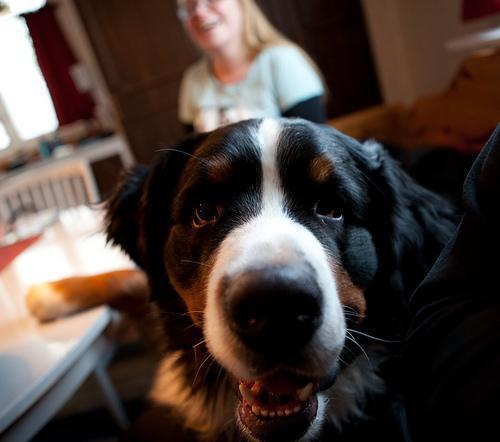How many of the dog's teeth are visible?
Give a very brief answer. 8. 